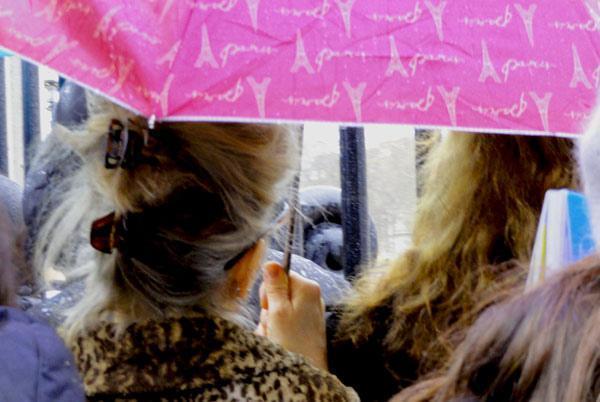What do the clips on the woman's head do for her?
Indicate the correct response and explain using: 'Answer: answer
Rationale: rationale.'
Options: Apply makeup, tie bread, relive headaches, hold hair. Answer: hold hair.
Rationale: The clips on the woman's head keep her hair in place. 